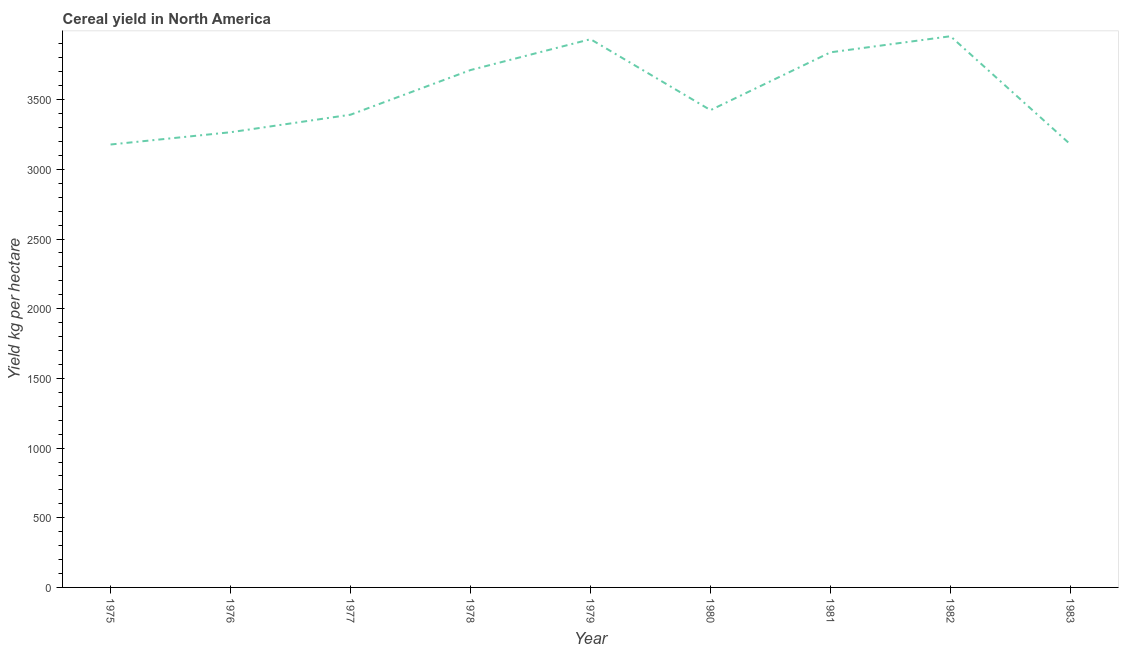What is the cereal yield in 1980?
Ensure brevity in your answer.  3425.23. Across all years, what is the maximum cereal yield?
Provide a short and direct response. 3955.53. Across all years, what is the minimum cereal yield?
Your answer should be compact. 3178.52. In which year was the cereal yield minimum?
Your answer should be compact. 1975. What is the sum of the cereal yield?
Your answer should be very brief. 3.19e+04. What is the difference between the cereal yield in 1975 and 1982?
Offer a very short reply. -777.01. What is the average cereal yield per year?
Make the answer very short. 3542.73. What is the median cereal yield?
Keep it short and to the point. 3425.23. Do a majority of the years between 1982 and 1981 (inclusive) have cereal yield greater than 1400 kg per hectare?
Keep it short and to the point. No. What is the ratio of the cereal yield in 1976 to that in 1980?
Your answer should be compact. 0.95. What is the difference between the highest and the second highest cereal yield?
Keep it short and to the point. 21.27. What is the difference between the highest and the lowest cereal yield?
Offer a terse response. 777.01. Does the graph contain any zero values?
Your response must be concise. No. Does the graph contain grids?
Keep it short and to the point. No. What is the title of the graph?
Provide a succinct answer. Cereal yield in North America. What is the label or title of the Y-axis?
Give a very brief answer. Yield kg per hectare. What is the Yield kg per hectare of 1975?
Your response must be concise. 3178.52. What is the Yield kg per hectare in 1976?
Offer a very short reply. 3266.63. What is the Yield kg per hectare in 1977?
Provide a short and direct response. 3392.46. What is the Yield kg per hectare in 1978?
Offer a terse response. 3712.92. What is the Yield kg per hectare of 1979?
Provide a succinct answer. 3934.25. What is the Yield kg per hectare of 1980?
Give a very brief answer. 3425.23. What is the Yield kg per hectare of 1981?
Ensure brevity in your answer.  3840.17. What is the Yield kg per hectare in 1982?
Keep it short and to the point. 3955.53. What is the Yield kg per hectare of 1983?
Offer a terse response. 3178.83. What is the difference between the Yield kg per hectare in 1975 and 1976?
Make the answer very short. -88.11. What is the difference between the Yield kg per hectare in 1975 and 1977?
Your answer should be compact. -213.94. What is the difference between the Yield kg per hectare in 1975 and 1978?
Keep it short and to the point. -534.4. What is the difference between the Yield kg per hectare in 1975 and 1979?
Keep it short and to the point. -755.73. What is the difference between the Yield kg per hectare in 1975 and 1980?
Provide a succinct answer. -246.71. What is the difference between the Yield kg per hectare in 1975 and 1981?
Ensure brevity in your answer.  -661.65. What is the difference between the Yield kg per hectare in 1975 and 1982?
Provide a short and direct response. -777.01. What is the difference between the Yield kg per hectare in 1975 and 1983?
Give a very brief answer. -0.32. What is the difference between the Yield kg per hectare in 1976 and 1977?
Ensure brevity in your answer.  -125.83. What is the difference between the Yield kg per hectare in 1976 and 1978?
Provide a short and direct response. -446.29. What is the difference between the Yield kg per hectare in 1976 and 1979?
Offer a terse response. -667.62. What is the difference between the Yield kg per hectare in 1976 and 1980?
Offer a terse response. -158.6. What is the difference between the Yield kg per hectare in 1976 and 1981?
Your answer should be very brief. -573.54. What is the difference between the Yield kg per hectare in 1976 and 1982?
Give a very brief answer. -688.89. What is the difference between the Yield kg per hectare in 1976 and 1983?
Your answer should be very brief. 87.8. What is the difference between the Yield kg per hectare in 1977 and 1978?
Your answer should be compact. -320.46. What is the difference between the Yield kg per hectare in 1977 and 1979?
Provide a short and direct response. -541.79. What is the difference between the Yield kg per hectare in 1977 and 1980?
Give a very brief answer. -32.77. What is the difference between the Yield kg per hectare in 1977 and 1981?
Provide a succinct answer. -447.71. What is the difference between the Yield kg per hectare in 1977 and 1982?
Your answer should be compact. -563.06. What is the difference between the Yield kg per hectare in 1977 and 1983?
Your answer should be very brief. 213.63. What is the difference between the Yield kg per hectare in 1978 and 1979?
Your response must be concise. -221.33. What is the difference between the Yield kg per hectare in 1978 and 1980?
Make the answer very short. 287.69. What is the difference between the Yield kg per hectare in 1978 and 1981?
Provide a short and direct response. -127.25. What is the difference between the Yield kg per hectare in 1978 and 1982?
Provide a succinct answer. -242.6. What is the difference between the Yield kg per hectare in 1978 and 1983?
Keep it short and to the point. 534.09. What is the difference between the Yield kg per hectare in 1979 and 1980?
Your response must be concise. 509.02. What is the difference between the Yield kg per hectare in 1979 and 1981?
Your response must be concise. 94.08. What is the difference between the Yield kg per hectare in 1979 and 1982?
Your answer should be very brief. -21.27. What is the difference between the Yield kg per hectare in 1979 and 1983?
Offer a very short reply. 755.42. What is the difference between the Yield kg per hectare in 1980 and 1981?
Offer a terse response. -414.94. What is the difference between the Yield kg per hectare in 1980 and 1982?
Provide a short and direct response. -530.29. What is the difference between the Yield kg per hectare in 1980 and 1983?
Ensure brevity in your answer.  246.4. What is the difference between the Yield kg per hectare in 1981 and 1982?
Your response must be concise. -115.35. What is the difference between the Yield kg per hectare in 1981 and 1983?
Provide a succinct answer. 661.34. What is the difference between the Yield kg per hectare in 1982 and 1983?
Make the answer very short. 776.69. What is the ratio of the Yield kg per hectare in 1975 to that in 1976?
Offer a very short reply. 0.97. What is the ratio of the Yield kg per hectare in 1975 to that in 1977?
Your answer should be compact. 0.94. What is the ratio of the Yield kg per hectare in 1975 to that in 1978?
Offer a terse response. 0.86. What is the ratio of the Yield kg per hectare in 1975 to that in 1979?
Your response must be concise. 0.81. What is the ratio of the Yield kg per hectare in 1975 to that in 1980?
Make the answer very short. 0.93. What is the ratio of the Yield kg per hectare in 1975 to that in 1981?
Offer a very short reply. 0.83. What is the ratio of the Yield kg per hectare in 1975 to that in 1982?
Keep it short and to the point. 0.8. What is the ratio of the Yield kg per hectare in 1976 to that in 1979?
Provide a short and direct response. 0.83. What is the ratio of the Yield kg per hectare in 1976 to that in 1980?
Ensure brevity in your answer.  0.95. What is the ratio of the Yield kg per hectare in 1976 to that in 1981?
Make the answer very short. 0.85. What is the ratio of the Yield kg per hectare in 1976 to that in 1982?
Your answer should be compact. 0.83. What is the ratio of the Yield kg per hectare in 1976 to that in 1983?
Ensure brevity in your answer.  1.03. What is the ratio of the Yield kg per hectare in 1977 to that in 1978?
Ensure brevity in your answer.  0.91. What is the ratio of the Yield kg per hectare in 1977 to that in 1979?
Provide a short and direct response. 0.86. What is the ratio of the Yield kg per hectare in 1977 to that in 1980?
Your answer should be very brief. 0.99. What is the ratio of the Yield kg per hectare in 1977 to that in 1981?
Provide a short and direct response. 0.88. What is the ratio of the Yield kg per hectare in 1977 to that in 1982?
Give a very brief answer. 0.86. What is the ratio of the Yield kg per hectare in 1977 to that in 1983?
Keep it short and to the point. 1.07. What is the ratio of the Yield kg per hectare in 1978 to that in 1979?
Keep it short and to the point. 0.94. What is the ratio of the Yield kg per hectare in 1978 to that in 1980?
Make the answer very short. 1.08. What is the ratio of the Yield kg per hectare in 1978 to that in 1981?
Provide a succinct answer. 0.97. What is the ratio of the Yield kg per hectare in 1978 to that in 1982?
Make the answer very short. 0.94. What is the ratio of the Yield kg per hectare in 1978 to that in 1983?
Ensure brevity in your answer.  1.17. What is the ratio of the Yield kg per hectare in 1979 to that in 1980?
Keep it short and to the point. 1.15. What is the ratio of the Yield kg per hectare in 1979 to that in 1982?
Provide a succinct answer. 0.99. What is the ratio of the Yield kg per hectare in 1979 to that in 1983?
Ensure brevity in your answer.  1.24. What is the ratio of the Yield kg per hectare in 1980 to that in 1981?
Give a very brief answer. 0.89. What is the ratio of the Yield kg per hectare in 1980 to that in 1982?
Provide a succinct answer. 0.87. What is the ratio of the Yield kg per hectare in 1980 to that in 1983?
Keep it short and to the point. 1.08. What is the ratio of the Yield kg per hectare in 1981 to that in 1983?
Offer a terse response. 1.21. What is the ratio of the Yield kg per hectare in 1982 to that in 1983?
Give a very brief answer. 1.24. 